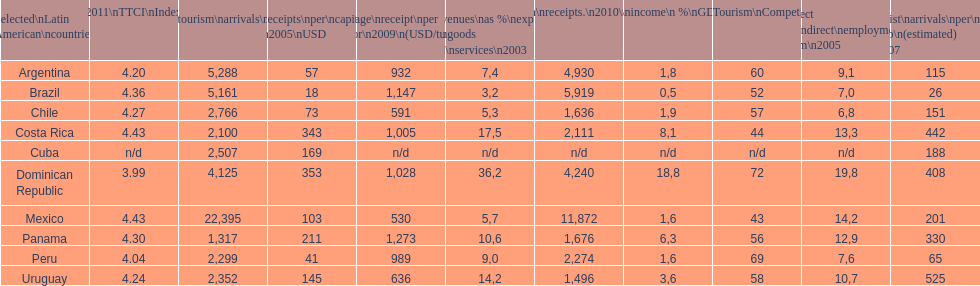Which latin american country had the largest number of tourism arrivals in 2010? Mexico. 